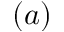<formula> <loc_0><loc_0><loc_500><loc_500>( a )</formula> 